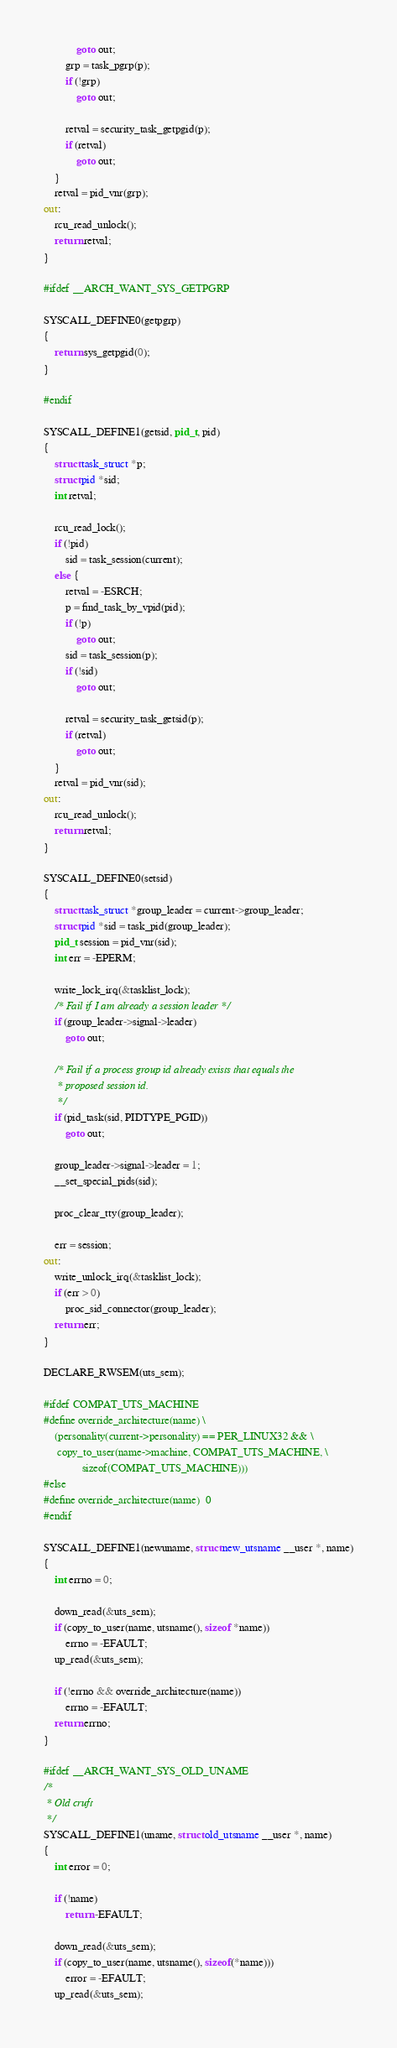Convert code to text. <code><loc_0><loc_0><loc_500><loc_500><_C_>			goto out;
		grp = task_pgrp(p);
		if (!grp)
			goto out;

		retval = security_task_getpgid(p);
		if (retval)
			goto out;
	}
	retval = pid_vnr(grp);
out:
	rcu_read_unlock();
	return retval;
}

#ifdef __ARCH_WANT_SYS_GETPGRP

SYSCALL_DEFINE0(getpgrp)
{
	return sys_getpgid(0);
}

#endif

SYSCALL_DEFINE1(getsid, pid_t, pid)
{
	struct task_struct *p;
	struct pid *sid;
	int retval;

	rcu_read_lock();
	if (!pid)
		sid = task_session(current);
	else {
		retval = -ESRCH;
		p = find_task_by_vpid(pid);
		if (!p)
			goto out;
		sid = task_session(p);
		if (!sid)
			goto out;

		retval = security_task_getsid(p);
		if (retval)
			goto out;
	}
	retval = pid_vnr(sid);
out:
	rcu_read_unlock();
	return retval;
}

SYSCALL_DEFINE0(setsid)
{
	struct task_struct *group_leader = current->group_leader;
	struct pid *sid = task_pid(group_leader);
	pid_t session = pid_vnr(sid);
	int err = -EPERM;

	write_lock_irq(&tasklist_lock);
	/* Fail if I am already a session leader */
	if (group_leader->signal->leader)
		goto out;

	/* Fail if a process group id already exists that equals the
	 * proposed session id.
	 */
	if (pid_task(sid, PIDTYPE_PGID))
		goto out;

	group_leader->signal->leader = 1;
	__set_special_pids(sid);

	proc_clear_tty(group_leader);

	err = session;
out:
	write_unlock_irq(&tasklist_lock);
	if (err > 0)
		proc_sid_connector(group_leader);
	return err;
}

DECLARE_RWSEM(uts_sem);

#ifdef COMPAT_UTS_MACHINE
#define override_architecture(name) \
	(personality(current->personality) == PER_LINUX32 && \
	 copy_to_user(name->machine, COMPAT_UTS_MACHINE, \
		      sizeof(COMPAT_UTS_MACHINE)))
#else
#define override_architecture(name)	0
#endif

SYSCALL_DEFINE1(newuname, struct new_utsname __user *, name)
{
	int errno = 0;

	down_read(&uts_sem);
	if (copy_to_user(name, utsname(), sizeof *name))
		errno = -EFAULT;
	up_read(&uts_sem);

	if (!errno && override_architecture(name))
		errno = -EFAULT;
	return errno;
}

#ifdef __ARCH_WANT_SYS_OLD_UNAME
/*
 * Old cruft
 */
SYSCALL_DEFINE1(uname, struct old_utsname __user *, name)
{
	int error = 0;

	if (!name)
		return -EFAULT;

	down_read(&uts_sem);
	if (copy_to_user(name, utsname(), sizeof(*name)))
		error = -EFAULT;
	up_read(&uts_sem);
</code> 